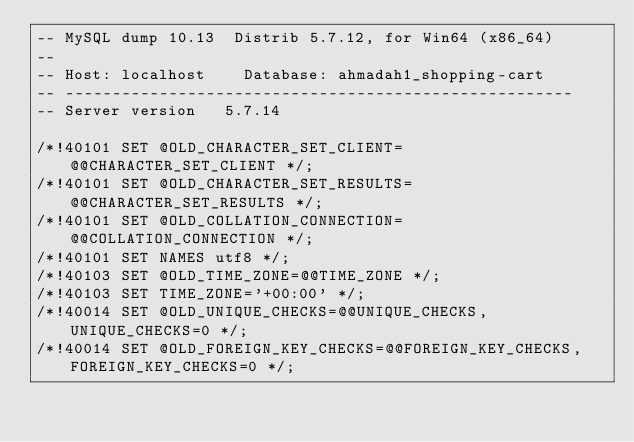Convert code to text. <code><loc_0><loc_0><loc_500><loc_500><_SQL_>-- MySQL dump 10.13  Distrib 5.7.12, for Win64 (x86_64)
--
-- Host: localhost    Database: ahmadah1_shopping-cart
-- ------------------------------------------------------
-- Server version	5.7.14

/*!40101 SET @OLD_CHARACTER_SET_CLIENT=@@CHARACTER_SET_CLIENT */;
/*!40101 SET @OLD_CHARACTER_SET_RESULTS=@@CHARACTER_SET_RESULTS */;
/*!40101 SET @OLD_COLLATION_CONNECTION=@@COLLATION_CONNECTION */;
/*!40101 SET NAMES utf8 */;
/*!40103 SET @OLD_TIME_ZONE=@@TIME_ZONE */;
/*!40103 SET TIME_ZONE='+00:00' */;
/*!40014 SET @OLD_UNIQUE_CHECKS=@@UNIQUE_CHECKS, UNIQUE_CHECKS=0 */;
/*!40014 SET @OLD_FOREIGN_KEY_CHECKS=@@FOREIGN_KEY_CHECKS, FOREIGN_KEY_CHECKS=0 */;</code> 